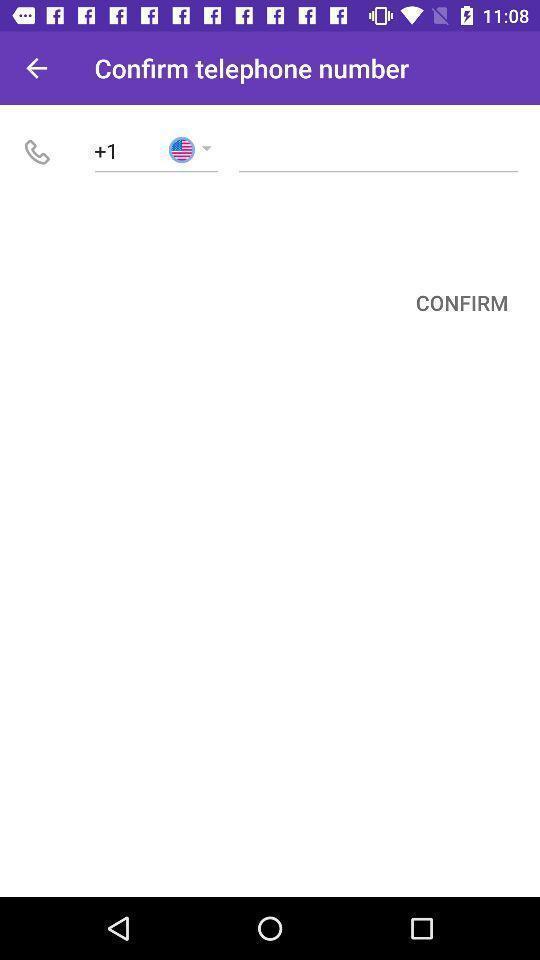Summarize the main components in this picture. Page for confirming phone number. 